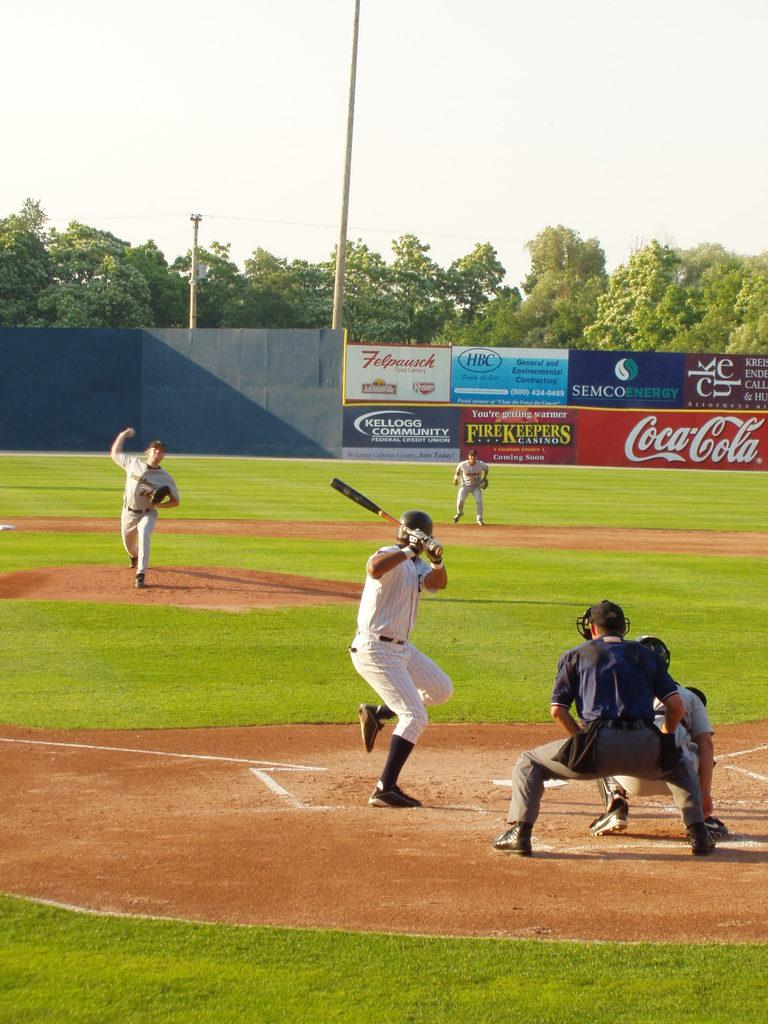<image>
Summarize the visual content of the image. Baseball players in a stadium with an ad that says Coca Cola. 